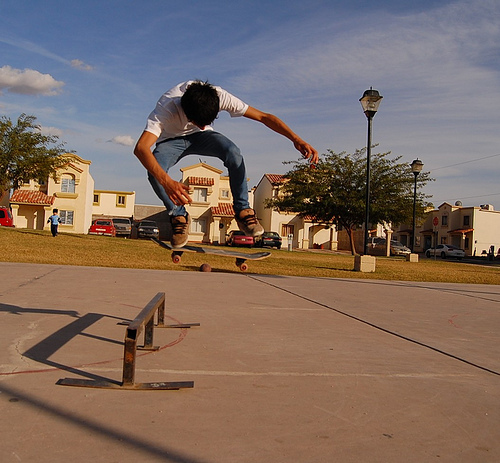What skateboarding trick is being performed here? The person appears to be performing an ollie, which is a basic skateboarding trick where the rider and board leap into the air without the use of the rider's hands. 